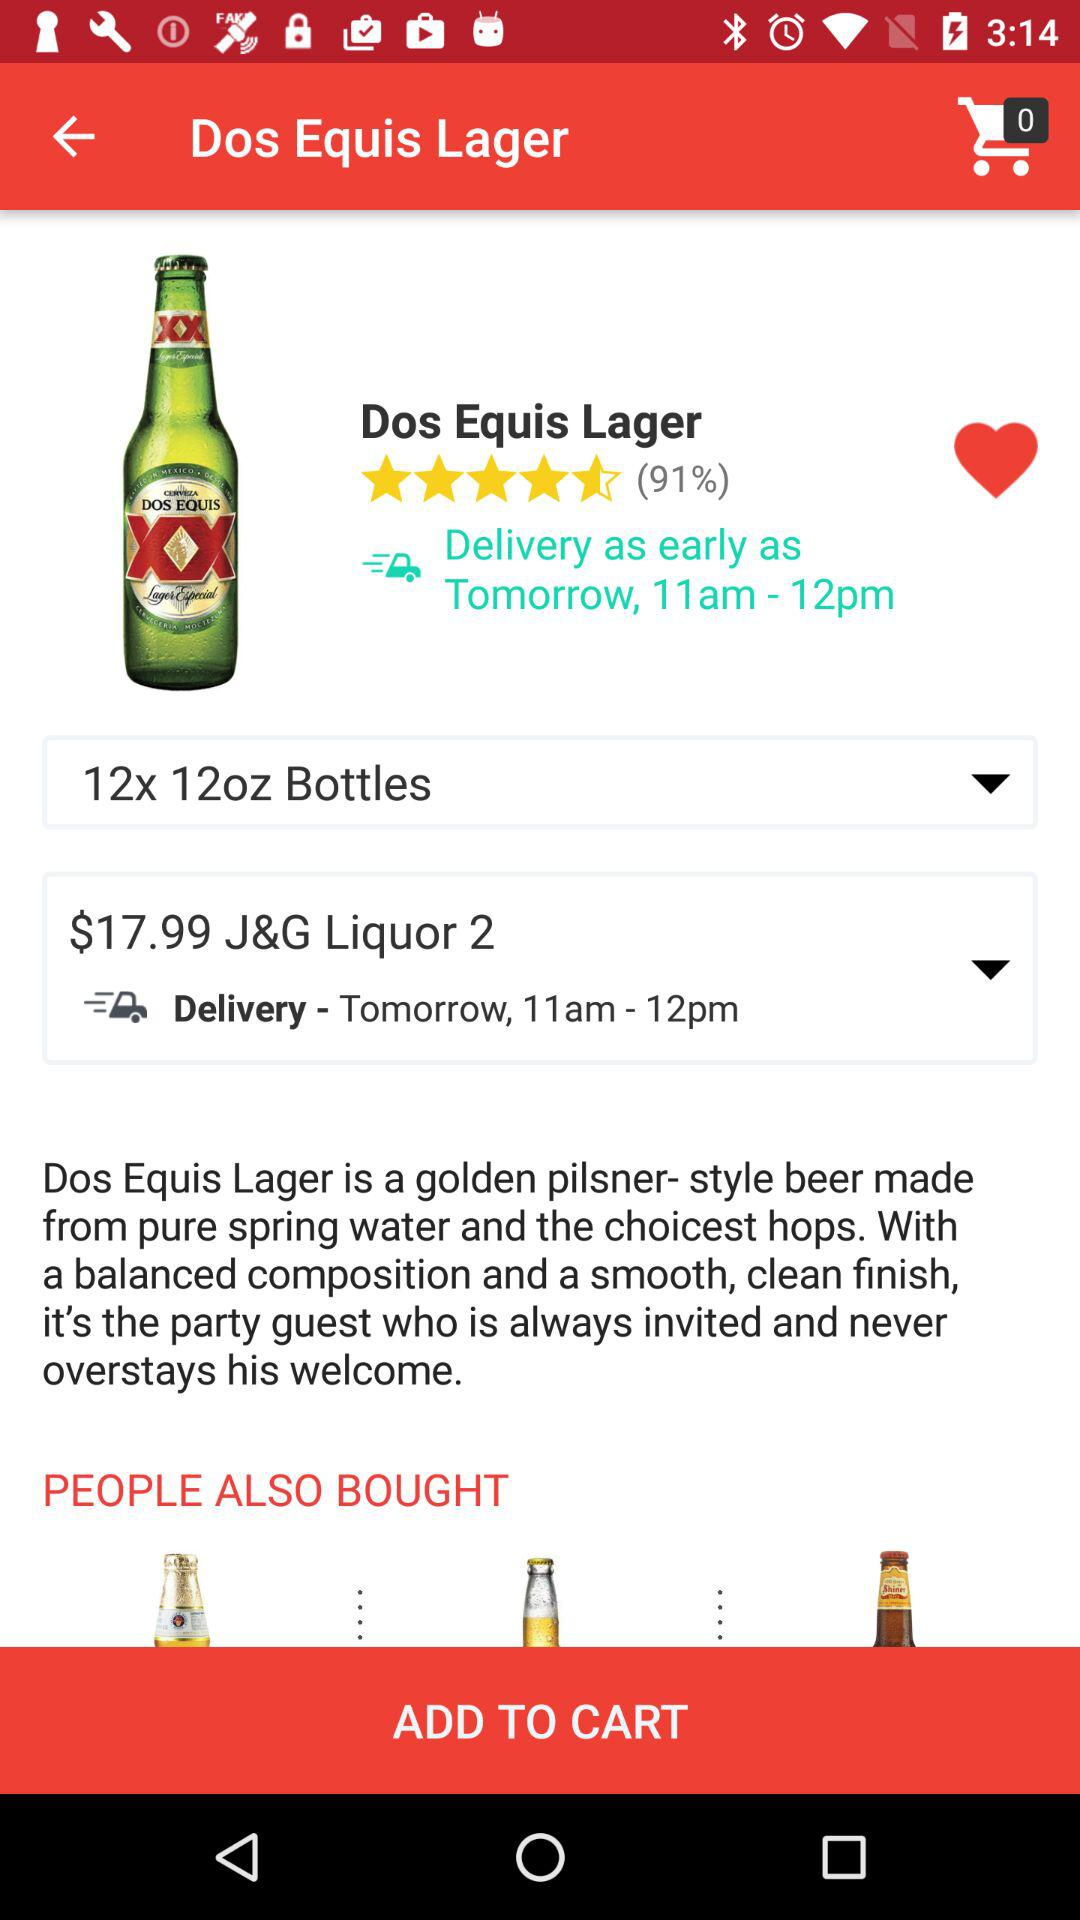What is the price? The price is $17.99. 